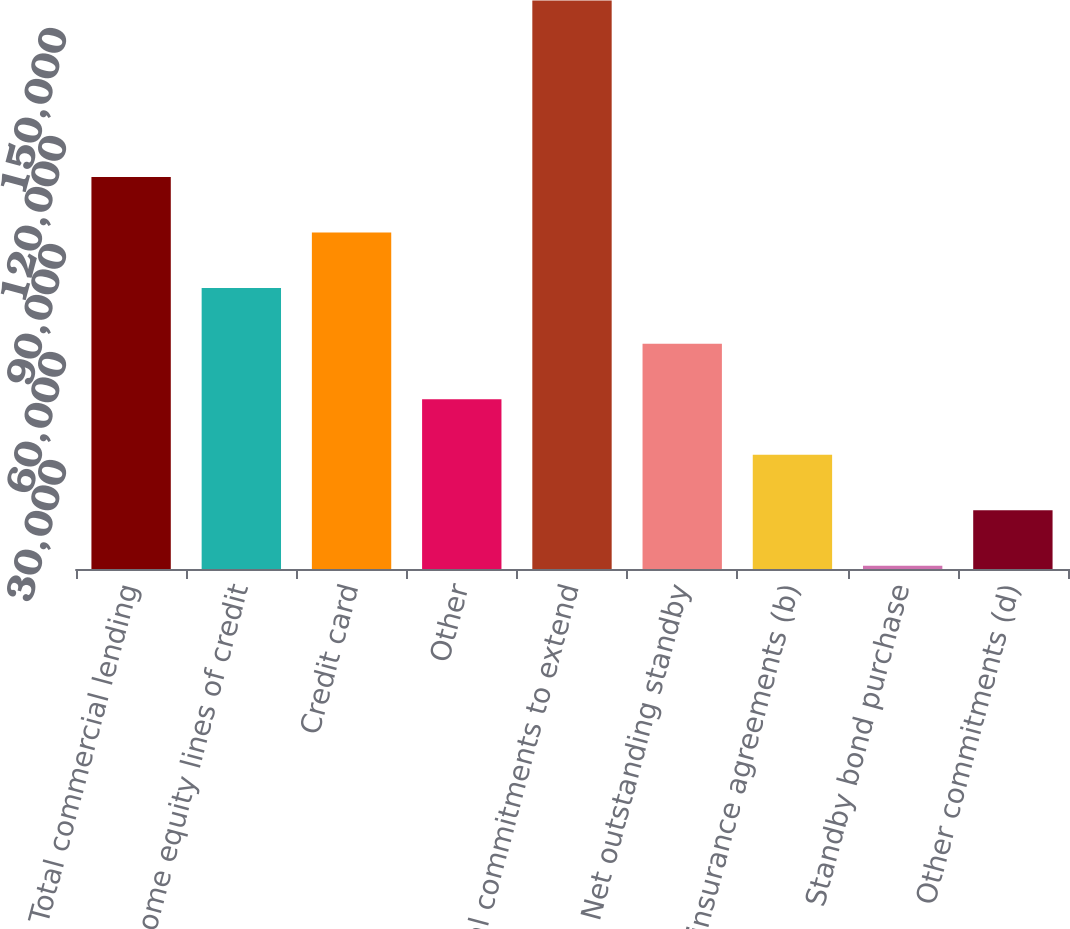<chart> <loc_0><loc_0><loc_500><loc_500><bar_chart><fcel>Total commercial lending<fcel>Home equity lines of credit<fcel>Credit card<fcel>Other<fcel>Total commitments to extend<fcel>Net outstanding standby<fcel>Reinsurance agreements (b)<fcel>Standby bond purchase<fcel>Other commitments (d)<nl><fcel>108872<fcel>78026<fcel>93449<fcel>47180<fcel>157912<fcel>62603<fcel>31757<fcel>911<fcel>16334<nl></chart> 